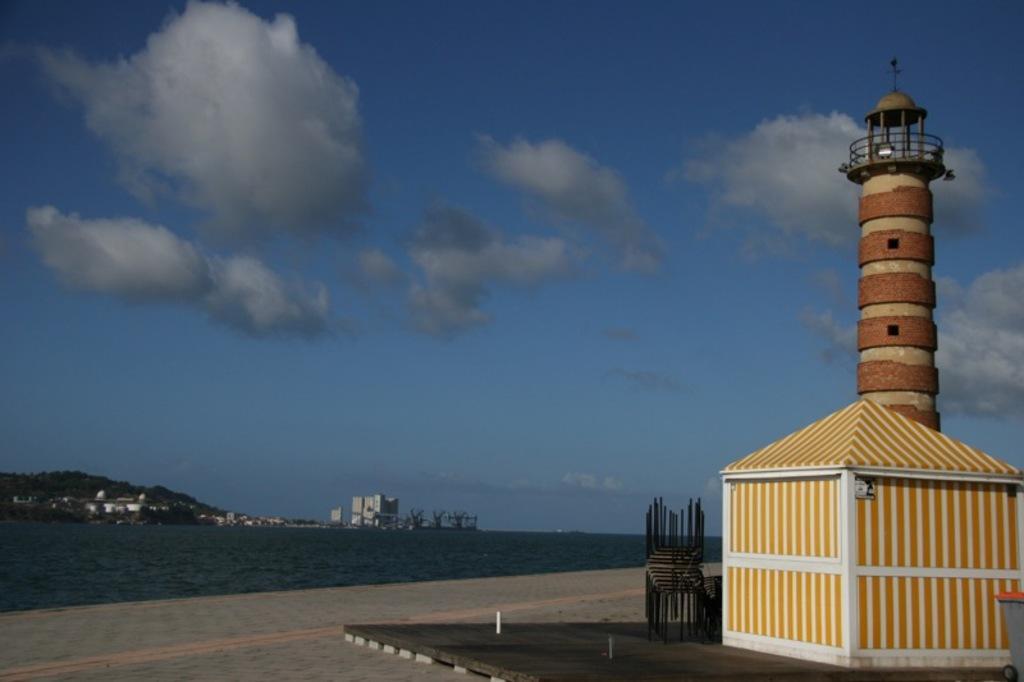In one or two sentences, can you explain what this image depicts? This image is taken outdoors. At the top of the image there is the sky with clouds. At the bottom of the image there is a floor. In the background there are a few trees, buildings and plants. In the middle of the image there is a river with water. On the right side of the image there is a wooden cabin and there is a tower and there is a railing. 